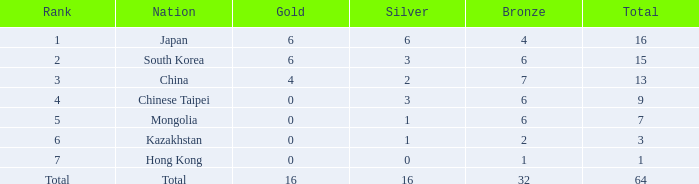In which case, is the silver the least, while having a gold more than 0, a total rank, and a bronze count of less than 32? None. 